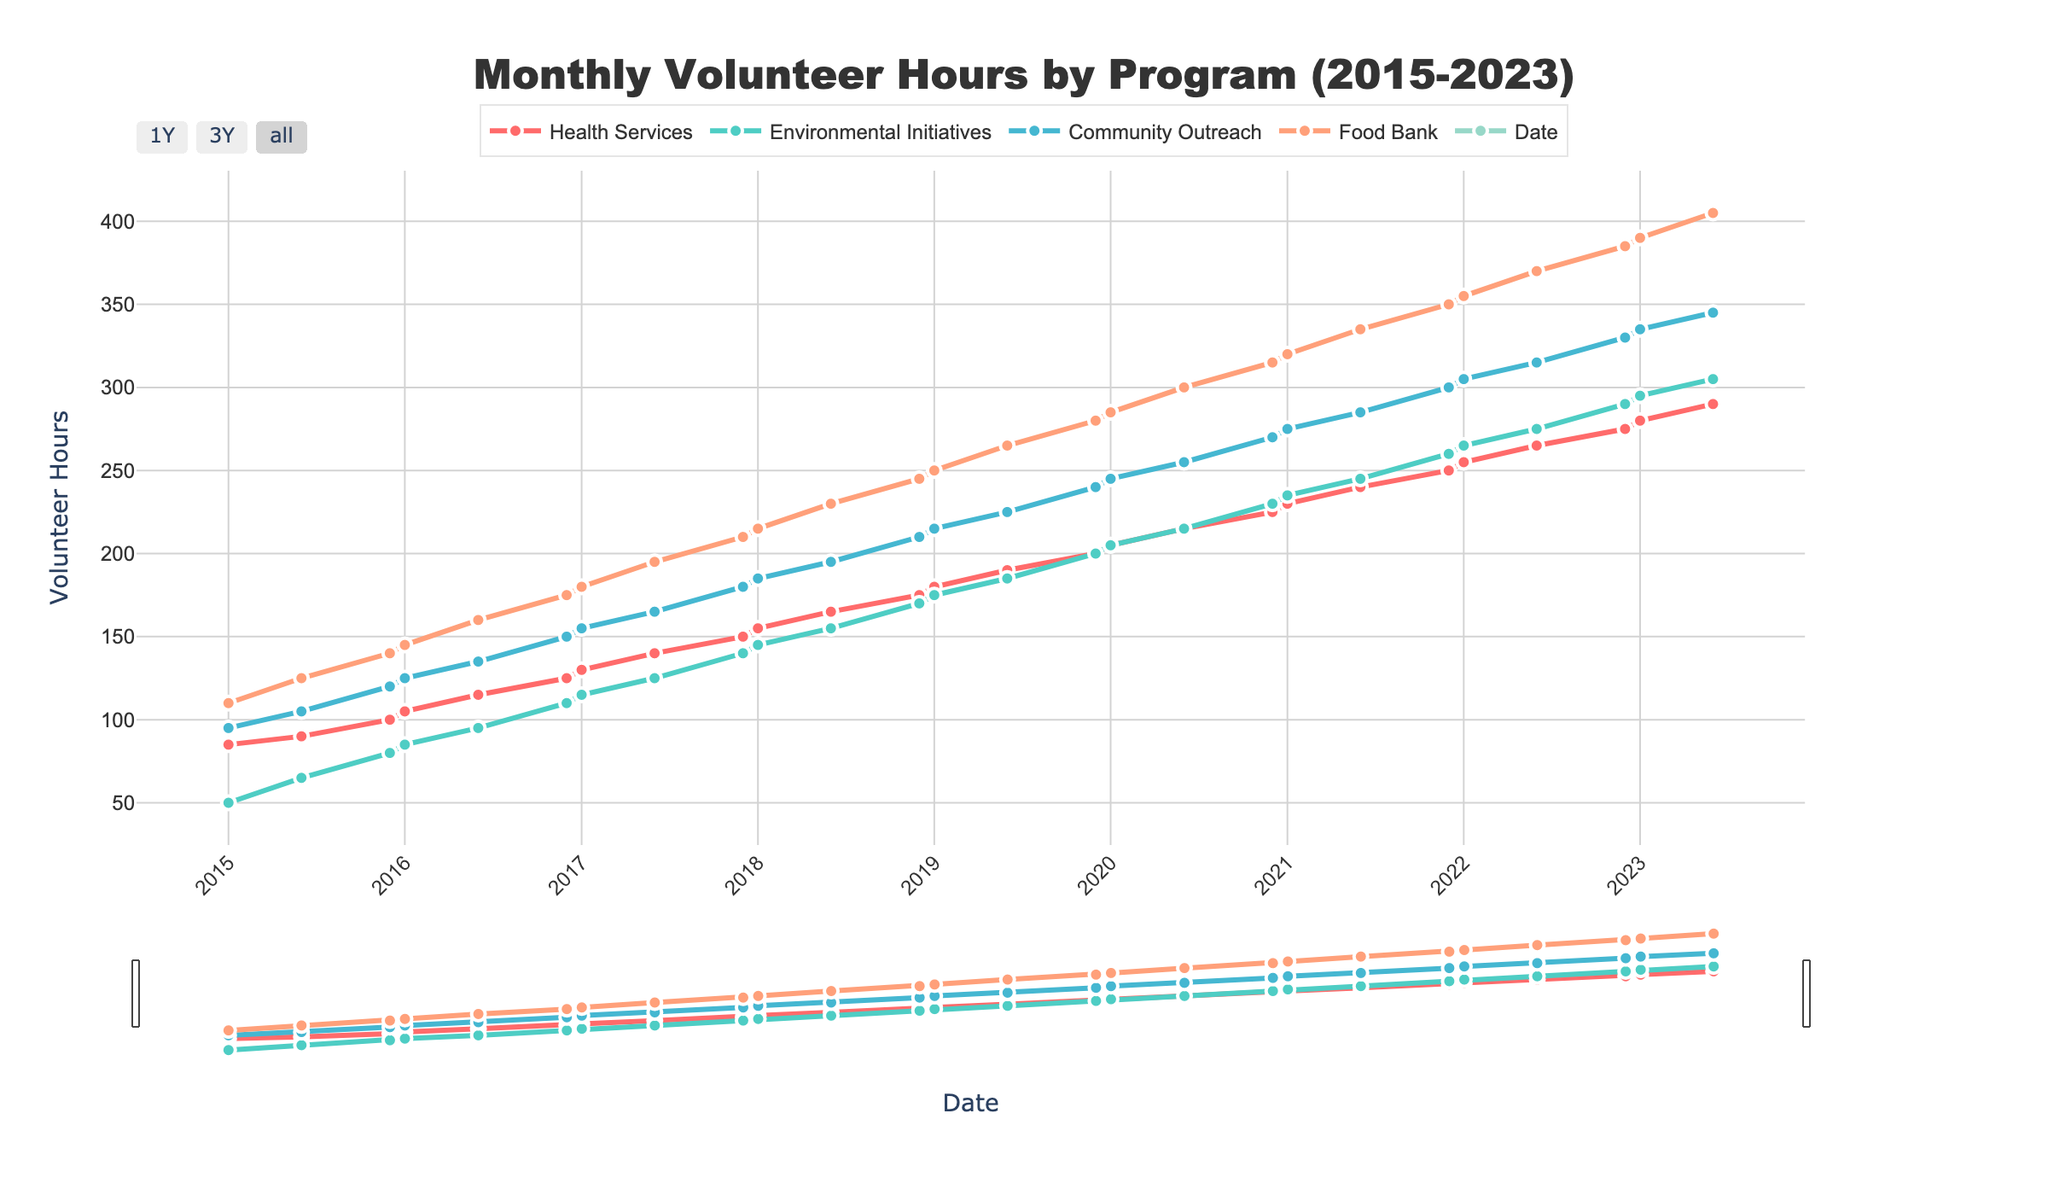What is the trend in monthly volunteer hours for the Health Services program from 2015 to 2023? The trend shows an upward pattern. To determine this, observe the line representing Health Services (color-coded green), starting around 85 hours in January 2015 and increasing steadily to 290 hours in June 2023.
Answer: Upward Which program had the highest increase in volunteer hours from January 2015 to June 2023? To find this, compare the increase for each program between these dates. The Education Program starts at 120 hours in January 2015 and rises to 415 hours in June 2023, which is the largest increase (295 hours).
Answer: Education Program In what year did the Community Outreach program first exceed 200 monthly volunteer hours? Locate the point where Community Outreach (orange line) first surpasses the 200-hour mark. According to the graph, this occurs around the middle of 2019.
Answer: 2019 During which month and year did the Food Bank program experience the most significant rise in volunteer hours? Look for the steepest slope in the Food Bank's line (purple). The largest increase appears between June 2020 and December 2020, where it jumps from approximately 300 to 315 hours.
Answer: June 2020 to December 2020 What is the average monthly volunteer hours for Environmental Initiatives in the years 2015, 2018, and 2021? To calculate this, find the Data points for each year:
- 2015: (50 + 65 + 80)/3 = 65
- 2018: (145 + 155 + 170)/3 = 156.67
- 2021: (235 + 245 + 260)/3 = 246.67
Then, sum these averages and divide by 3: (65 + 156.67 + 246.67)/3 ≈ 156.78
Answer: ≈ 156.78 How did volunteer hours for the Education Program and Health Services compare in January 2021? In January 2021, the Education Program logs 330 hours and Health Services registers 230 hours. The Education Program has 100 more hours than Health Services.
Answer: Education Program has 100 more hours Which program had the most consistent growth in volunteer hours from 2015 to 2023? The most consistent growth can be identified by the smoothest and steadiest upward slope. Reviewing the lines, the Education Program consistently grows without major drops or fluctuations.
Answer: Education Program Between the Environmental Initiatives and Community Outreach programs, which had wider fluctuations in volunteer hours from 2015 to 2023? Compare the volatility of the two lines. The Environmental Initiatives program shows more variability in the steepness and dips, whereas Community Outreach appears more stable.
Answer: Environmental Initiatives Is there any month where all programs experienced simultaneous growth? Review the chart for points where all programs' lines rise synchronously. The chart highlights December 2018, where all programs show increases compared to the preceding data points.
Answer: December 2018 